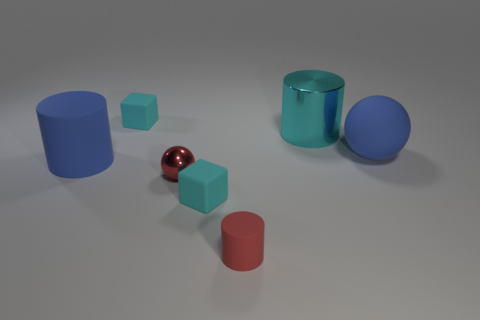How is the lighting arranged in this scene to create such clear reflections on the objects? The lighting in the scene appears to come from a high angle based on the direction of the shadows and reflections on the objects. It's diffused, suggesting that there might be one or more light sources, or a softbox, casting soft shadows to give the objects a three-dimensional appearance and highlight their textures. 